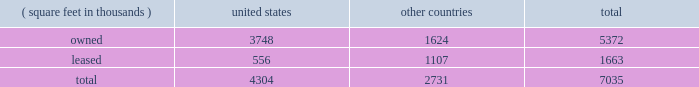Item 2 : properties information concerning applied's properties at october 25 , 2015 is set forth below: .
Because of the interrelation of applied's operations , properties within a country may be shared by the segments operating within that country .
The company's headquarters offices are in santa clara , california .
Products in silicon systems are manufactured in austin , texas ; gloucester , massachusetts ; rehovot , israel ; and singapore .
Remanufactured equipment products in the applied global services segment are produced primarily in austin , texas .
Products in the display segment are manufactured in tainan , taiwan and santa clara , california .
Products in the energy and environmental solutions segment are primarily manufactured in alzenau , germany and treviso , italy .
Applied also owns and leases offices , plants and warehouse locations in many locations throughout the world , including in europe , japan , north america ( principally the united states ) , israel , china , india , korea , southeast asia and taiwan .
These facilities are principally used for manufacturing ; research , development and engineering ; and marketing , sales and customer support .
Applied also owns a total of approximately 139 acres of buildable land in texas , california , israel and italy that could accommodate additional building space .
Applied considers the properties that it owns or leases as adequate to meet its current and future requirements .
Applied regularly assesses the size , capability and location of its global infrastructure and periodically makes adjustments based on these assessments. .
Based on the table , how much more square feet is owned outside the united states? 
Rationale: this is a pretty self explanatory question but units are needed or the answer is incorrect .
Computations: (7035 - 4304)
Answer: 2731.0. 